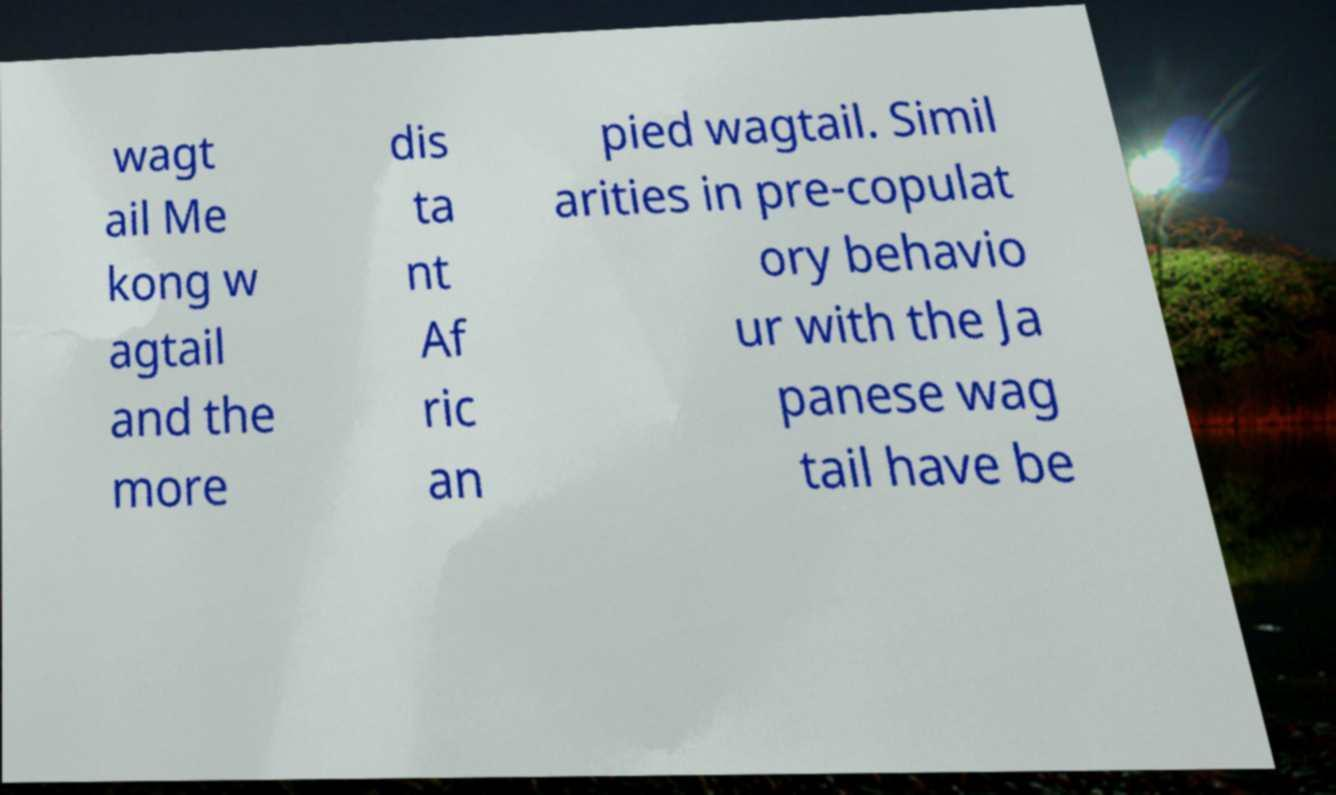Please identify and transcribe the text found in this image. wagt ail Me kong w agtail and the more dis ta nt Af ric an pied wagtail. Simil arities in pre-copulat ory behavio ur with the Ja panese wag tail have be 